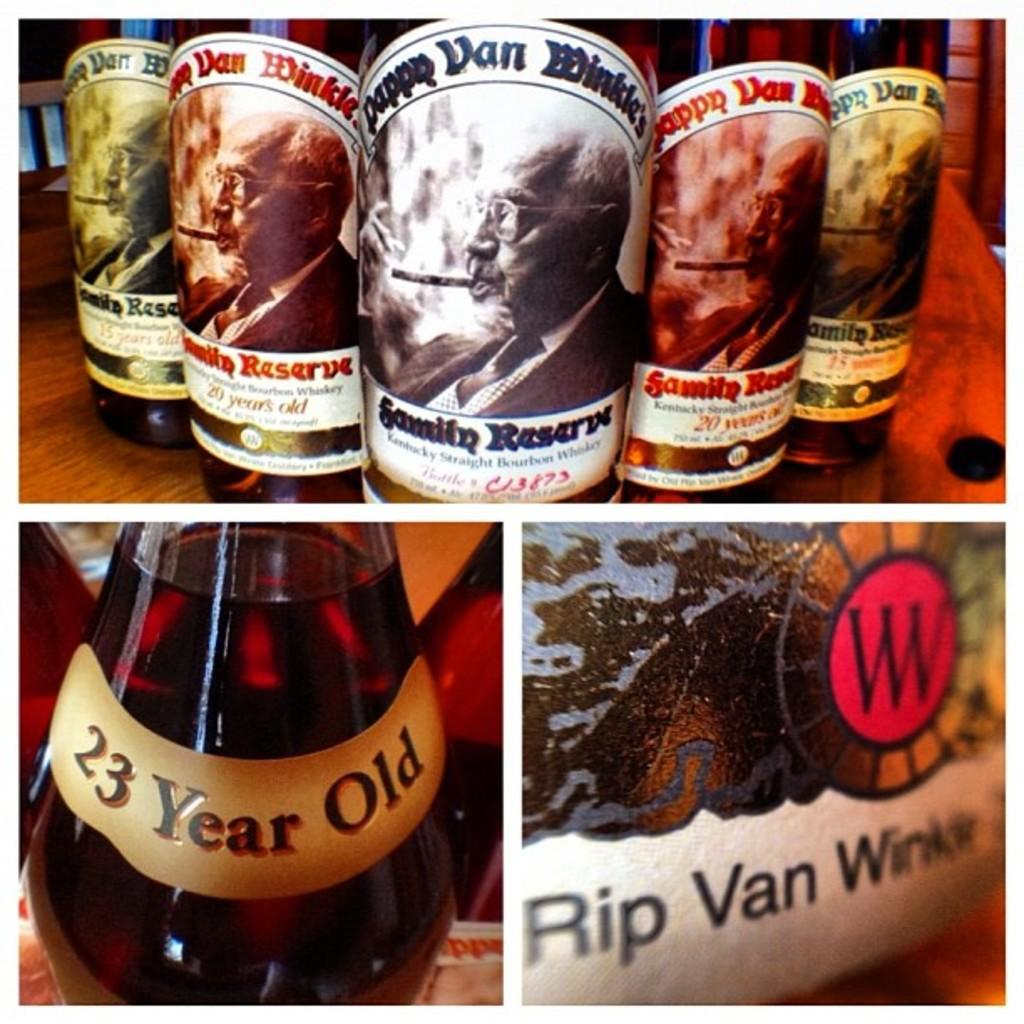<image>
Provide a brief description of the given image. Bottles have the name Rip Van Winkle on them. 